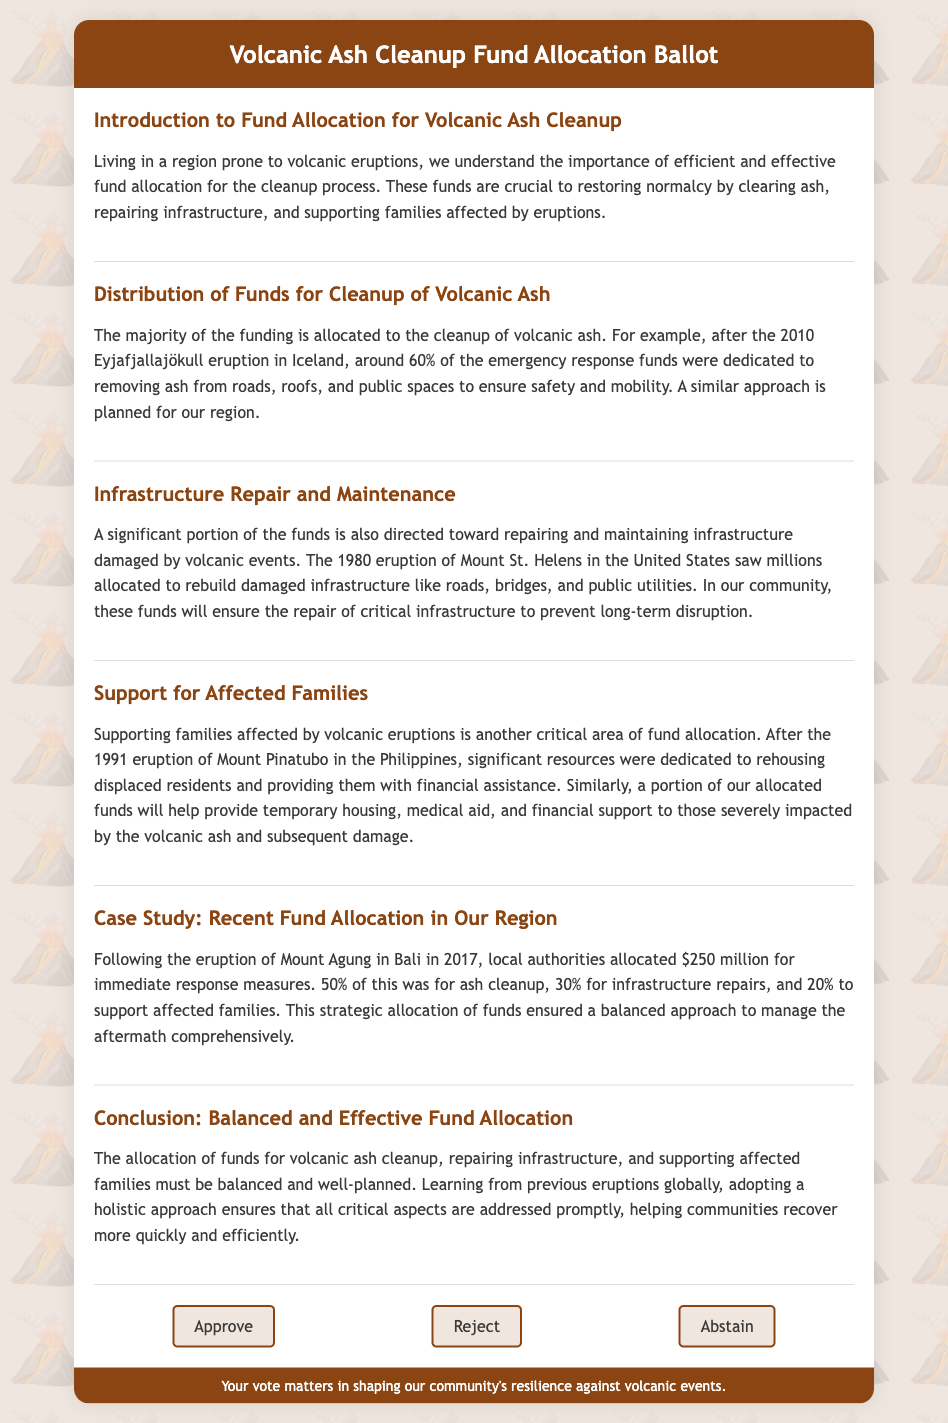What percentage of funds is allocated for the cleanup of volcanic ash? The document specifies that 60% of emergency response funds are dedicated to ash cleanup based on previous eruptions.
Answer: 60% What event is cited as an example for infrastructure repair funding? The document mentions the 1980 eruption of Mount St. Helens in the United States to illustrate infrastructure repair needs.
Answer: Mount St. Helens What does the fund allocation plan for supporting affected families? The document outlines that funds will help provide temporary housing, medical aid, and financial support to affected families.
Answer: Temporary housing, medical aid, financial support According to the case study, what was the total allocation for immediate response measures after the Mount Agung eruption? The document states that local authorities allocated $250 million for immediate response measures following the eruption of Mount Agung.
Answer: $250 million What was the percentage allocated specifically for supporting affected families in the case study? The document notes that 20% of the funds were designated to support affected families in the case study.
Answer: 20% What is the main goal of the funds allocated as stated in the document? The primary aim of the allocated funds is to restore normalcy by addressing cleanup, infrastructure repair, and family support after volcanic eruptions.
Answer: Restore normalcy What is the significance of learning from previous eruptions according to the conclusion? The conclusion emphasizes the importance of adopting a holistic approach based on lessons from previous eruptions to ensure comprehensive management of volcanic aftermath.
Answer: Ensure comprehensive management What type of document is this ballot classified as? The document is a ballot regarding the allocation of funds for volcanic ash cleanup and support for affected families.
Answer: Ballot 